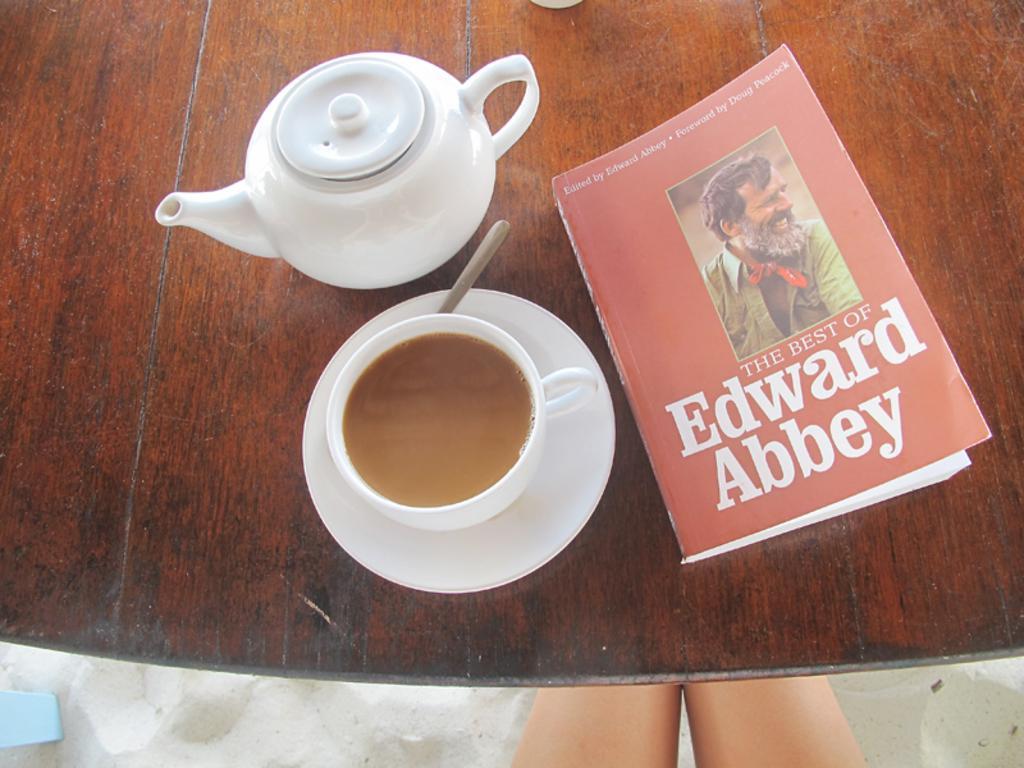In one or two sentences, can you explain what this image depicts? In this image there is a table and we can see a book, teapot, a cup containing teaspoon and a saucer placed on the table. At the bottom we can see a person's legs. 